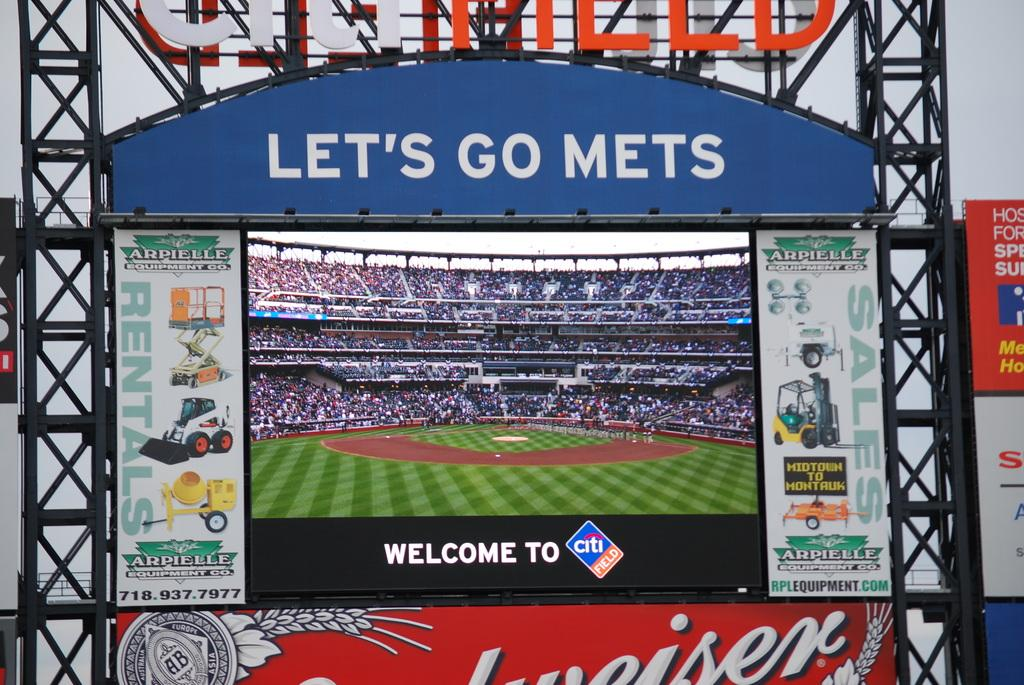What is the main object in the image? There is a screen in the image. How is the screen supported or held up? The screen is attached to rods. What surrounds the screen in the image? There are hoardings around the screen. What can be seen on the screen? People are visible on the screen. What type of humor can be seen in the flag displayed on the screen? There is no flag displayed on the screen, and therefore no humor can be observed. 